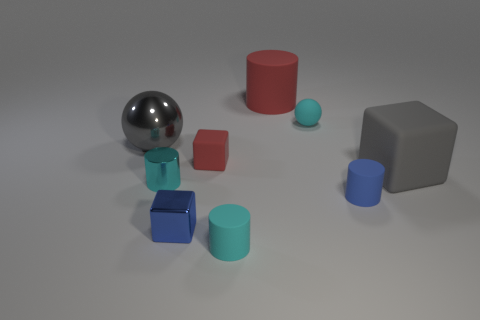Subtract all cylinders. How many objects are left? 5 Subtract 0 purple cylinders. How many objects are left? 9 Subtract all small cyan balls. Subtract all big red rubber cylinders. How many objects are left? 7 Add 7 tiny shiny cylinders. How many tiny shiny cylinders are left? 8 Add 6 metallic cylinders. How many metallic cylinders exist? 7 